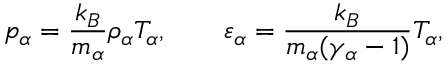<formula> <loc_0><loc_0><loc_500><loc_500>p _ { \alpha } = \frac { k _ { B } } { m _ { \alpha } } \rho _ { \alpha } T _ { \alpha } , \quad \varepsilon _ { \alpha } = \frac { k _ { B } } { m _ { \alpha } ( \gamma _ { \alpha } - 1 ) } T _ { \alpha } ,</formula> 